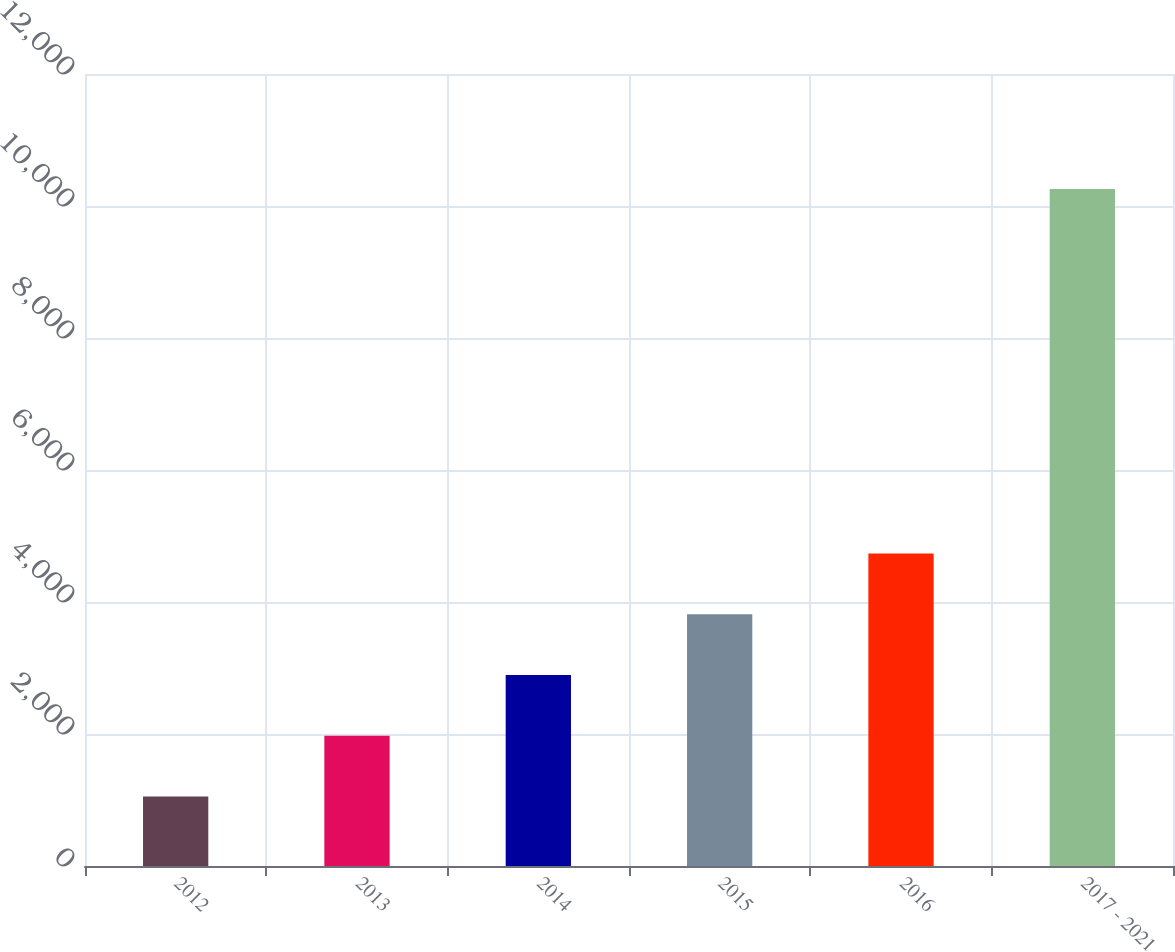Convert chart. <chart><loc_0><loc_0><loc_500><loc_500><bar_chart><fcel>2012<fcel>2013<fcel>2014<fcel>2015<fcel>2016<fcel>2017 - 2021<nl><fcel>1052<fcel>1972.6<fcel>2893.2<fcel>3813.8<fcel>4734.4<fcel>10258<nl></chart> 